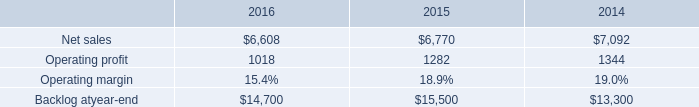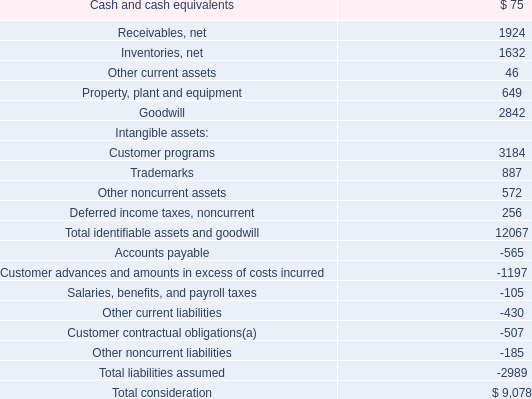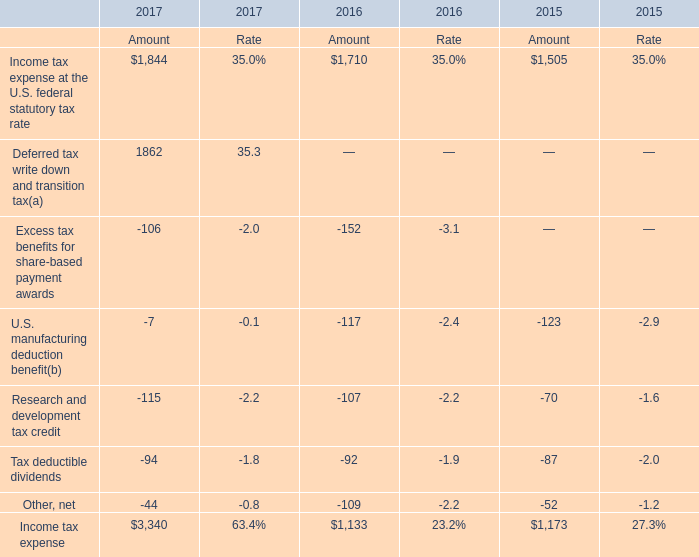what is the growth rate of net sales from 2015 to 2016? 
Computations: ((6608 - 6770) / 6770)
Answer: -0.02393. 